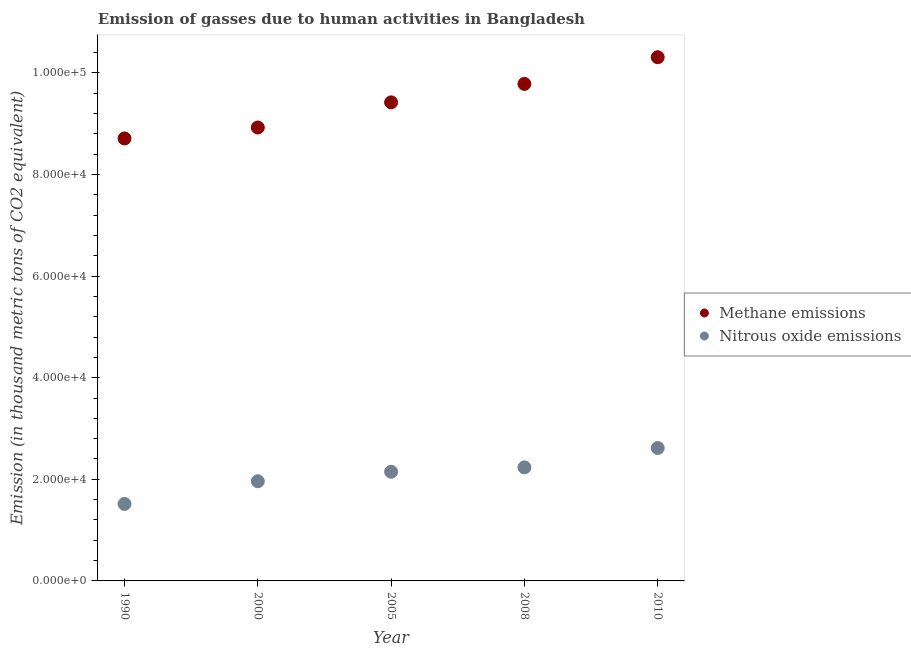How many different coloured dotlines are there?
Offer a very short reply. 2. What is the amount of methane emissions in 2008?
Give a very brief answer. 9.78e+04. Across all years, what is the maximum amount of methane emissions?
Your response must be concise. 1.03e+05. Across all years, what is the minimum amount of methane emissions?
Provide a short and direct response. 8.71e+04. What is the total amount of nitrous oxide emissions in the graph?
Your response must be concise. 1.05e+05. What is the difference between the amount of methane emissions in 2005 and that in 2008?
Provide a succinct answer. -3634.3. What is the difference between the amount of nitrous oxide emissions in 1990 and the amount of methane emissions in 2008?
Give a very brief answer. -8.27e+04. What is the average amount of methane emissions per year?
Keep it short and to the point. 9.43e+04. In the year 2010, what is the difference between the amount of methane emissions and amount of nitrous oxide emissions?
Provide a short and direct response. 7.69e+04. In how many years, is the amount of nitrous oxide emissions greater than 56000 thousand metric tons?
Your answer should be very brief. 0. What is the ratio of the amount of nitrous oxide emissions in 1990 to that in 2000?
Keep it short and to the point. 0.77. Is the amount of nitrous oxide emissions in 1990 less than that in 2000?
Give a very brief answer. Yes. What is the difference between the highest and the second highest amount of nitrous oxide emissions?
Your answer should be compact. 3811.2. What is the difference between the highest and the lowest amount of nitrous oxide emissions?
Make the answer very short. 1.10e+04. In how many years, is the amount of methane emissions greater than the average amount of methane emissions taken over all years?
Your answer should be compact. 2. How many dotlines are there?
Your answer should be very brief. 2. What is the difference between two consecutive major ticks on the Y-axis?
Make the answer very short. 2.00e+04. Where does the legend appear in the graph?
Offer a very short reply. Center right. How are the legend labels stacked?
Your answer should be compact. Vertical. What is the title of the graph?
Ensure brevity in your answer.  Emission of gasses due to human activities in Bangladesh. What is the label or title of the X-axis?
Offer a very short reply. Year. What is the label or title of the Y-axis?
Offer a terse response. Emission (in thousand metric tons of CO2 equivalent). What is the Emission (in thousand metric tons of CO2 equivalent) of Methane emissions in 1990?
Offer a terse response. 8.71e+04. What is the Emission (in thousand metric tons of CO2 equivalent) in Nitrous oxide emissions in 1990?
Your answer should be compact. 1.52e+04. What is the Emission (in thousand metric tons of CO2 equivalent) in Methane emissions in 2000?
Keep it short and to the point. 8.92e+04. What is the Emission (in thousand metric tons of CO2 equivalent) of Nitrous oxide emissions in 2000?
Offer a very short reply. 1.96e+04. What is the Emission (in thousand metric tons of CO2 equivalent) in Methane emissions in 2005?
Offer a terse response. 9.42e+04. What is the Emission (in thousand metric tons of CO2 equivalent) of Nitrous oxide emissions in 2005?
Your response must be concise. 2.15e+04. What is the Emission (in thousand metric tons of CO2 equivalent) in Methane emissions in 2008?
Provide a short and direct response. 9.78e+04. What is the Emission (in thousand metric tons of CO2 equivalent) of Nitrous oxide emissions in 2008?
Your answer should be compact. 2.23e+04. What is the Emission (in thousand metric tons of CO2 equivalent) of Methane emissions in 2010?
Keep it short and to the point. 1.03e+05. What is the Emission (in thousand metric tons of CO2 equivalent) in Nitrous oxide emissions in 2010?
Your answer should be very brief. 2.62e+04. Across all years, what is the maximum Emission (in thousand metric tons of CO2 equivalent) in Methane emissions?
Your answer should be very brief. 1.03e+05. Across all years, what is the maximum Emission (in thousand metric tons of CO2 equivalent) in Nitrous oxide emissions?
Provide a succinct answer. 2.62e+04. Across all years, what is the minimum Emission (in thousand metric tons of CO2 equivalent) of Methane emissions?
Make the answer very short. 8.71e+04. Across all years, what is the minimum Emission (in thousand metric tons of CO2 equivalent) of Nitrous oxide emissions?
Offer a terse response. 1.52e+04. What is the total Emission (in thousand metric tons of CO2 equivalent) of Methane emissions in the graph?
Your answer should be very brief. 4.71e+05. What is the total Emission (in thousand metric tons of CO2 equivalent) in Nitrous oxide emissions in the graph?
Give a very brief answer. 1.05e+05. What is the difference between the Emission (in thousand metric tons of CO2 equivalent) in Methane emissions in 1990 and that in 2000?
Your answer should be compact. -2153.8. What is the difference between the Emission (in thousand metric tons of CO2 equivalent) in Nitrous oxide emissions in 1990 and that in 2000?
Ensure brevity in your answer.  -4463.6. What is the difference between the Emission (in thousand metric tons of CO2 equivalent) of Methane emissions in 1990 and that in 2005?
Your answer should be compact. -7104.5. What is the difference between the Emission (in thousand metric tons of CO2 equivalent) of Nitrous oxide emissions in 1990 and that in 2005?
Provide a short and direct response. -6336.1. What is the difference between the Emission (in thousand metric tons of CO2 equivalent) of Methane emissions in 1990 and that in 2008?
Your response must be concise. -1.07e+04. What is the difference between the Emission (in thousand metric tons of CO2 equivalent) of Nitrous oxide emissions in 1990 and that in 2008?
Your answer should be compact. -7197.8. What is the difference between the Emission (in thousand metric tons of CO2 equivalent) in Methane emissions in 1990 and that in 2010?
Give a very brief answer. -1.60e+04. What is the difference between the Emission (in thousand metric tons of CO2 equivalent) in Nitrous oxide emissions in 1990 and that in 2010?
Make the answer very short. -1.10e+04. What is the difference between the Emission (in thousand metric tons of CO2 equivalent) of Methane emissions in 2000 and that in 2005?
Provide a short and direct response. -4950.7. What is the difference between the Emission (in thousand metric tons of CO2 equivalent) of Nitrous oxide emissions in 2000 and that in 2005?
Your response must be concise. -1872.5. What is the difference between the Emission (in thousand metric tons of CO2 equivalent) of Methane emissions in 2000 and that in 2008?
Ensure brevity in your answer.  -8585. What is the difference between the Emission (in thousand metric tons of CO2 equivalent) of Nitrous oxide emissions in 2000 and that in 2008?
Keep it short and to the point. -2734.2. What is the difference between the Emission (in thousand metric tons of CO2 equivalent) in Methane emissions in 2000 and that in 2010?
Offer a terse response. -1.38e+04. What is the difference between the Emission (in thousand metric tons of CO2 equivalent) of Nitrous oxide emissions in 2000 and that in 2010?
Offer a very short reply. -6545.4. What is the difference between the Emission (in thousand metric tons of CO2 equivalent) of Methane emissions in 2005 and that in 2008?
Your answer should be very brief. -3634.3. What is the difference between the Emission (in thousand metric tons of CO2 equivalent) of Nitrous oxide emissions in 2005 and that in 2008?
Provide a succinct answer. -861.7. What is the difference between the Emission (in thousand metric tons of CO2 equivalent) of Methane emissions in 2005 and that in 2010?
Make the answer very short. -8885.7. What is the difference between the Emission (in thousand metric tons of CO2 equivalent) in Nitrous oxide emissions in 2005 and that in 2010?
Offer a very short reply. -4672.9. What is the difference between the Emission (in thousand metric tons of CO2 equivalent) in Methane emissions in 2008 and that in 2010?
Your answer should be compact. -5251.4. What is the difference between the Emission (in thousand metric tons of CO2 equivalent) of Nitrous oxide emissions in 2008 and that in 2010?
Make the answer very short. -3811.2. What is the difference between the Emission (in thousand metric tons of CO2 equivalent) of Methane emissions in 1990 and the Emission (in thousand metric tons of CO2 equivalent) of Nitrous oxide emissions in 2000?
Offer a terse response. 6.75e+04. What is the difference between the Emission (in thousand metric tons of CO2 equivalent) of Methane emissions in 1990 and the Emission (in thousand metric tons of CO2 equivalent) of Nitrous oxide emissions in 2005?
Provide a short and direct response. 6.56e+04. What is the difference between the Emission (in thousand metric tons of CO2 equivalent) of Methane emissions in 1990 and the Emission (in thousand metric tons of CO2 equivalent) of Nitrous oxide emissions in 2008?
Your response must be concise. 6.47e+04. What is the difference between the Emission (in thousand metric tons of CO2 equivalent) of Methane emissions in 1990 and the Emission (in thousand metric tons of CO2 equivalent) of Nitrous oxide emissions in 2010?
Make the answer very short. 6.09e+04. What is the difference between the Emission (in thousand metric tons of CO2 equivalent) of Methane emissions in 2000 and the Emission (in thousand metric tons of CO2 equivalent) of Nitrous oxide emissions in 2005?
Your answer should be very brief. 6.78e+04. What is the difference between the Emission (in thousand metric tons of CO2 equivalent) of Methane emissions in 2000 and the Emission (in thousand metric tons of CO2 equivalent) of Nitrous oxide emissions in 2008?
Provide a short and direct response. 6.69e+04. What is the difference between the Emission (in thousand metric tons of CO2 equivalent) of Methane emissions in 2000 and the Emission (in thousand metric tons of CO2 equivalent) of Nitrous oxide emissions in 2010?
Your response must be concise. 6.31e+04. What is the difference between the Emission (in thousand metric tons of CO2 equivalent) of Methane emissions in 2005 and the Emission (in thousand metric tons of CO2 equivalent) of Nitrous oxide emissions in 2008?
Your answer should be very brief. 7.18e+04. What is the difference between the Emission (in thousand metric tons of CO2 equivalent) in Methane emissions in 2005 and the Emission (in thousand metric tons of CO2 equivalent) in Nitrous oxide emissions in 2010?
Your answer should be compact. 6.80e+04. What is the difference between the Emission (in thousand metric tons of CO2 equivalent) in Methane emissions in 2008 and the Emission (in thousand metric tons of CO2 equivalent) in Nitrous oxide emissions in 2010?
Keep it short and to the point. 7.17e+04. What is the average Emission (in thousand metric tons of CO2 equivalent) in Methane emissions per year?
Your answer should be compact. 9.43e+04. What is the average Emission (in thousand metric tons of CO2 equivalent) in Nitrous oxide emissions per year?
Your answer should be very brief. 2.10e+04. In the year 1990, what is the difference between the Emission (in thousand metric tons of CO2 equivalent) in Methane emissions and Emission (in thousand metric tons of CO2 equivalent) in Nitrous oxide emissions?
Your answer should be compact. 7.19e+04. In the year 2000, what is the difference between the Emission (in thousand metric tons of CO2 equivalent) in Methane emissions and Emission (in thousand metric tons of CO2 equivalent) in Nitrous oxide emissions?
Offer a very short reply. 6.96e+04. In the year 2005, what is the difference between the Emission (in thousand metric tons of CO2 equivalent) of Methane emissions and Emission (in thousand metric tons of CO2 equivalent) of Nitrous oxide emissions?
Provide a succinct answer. 7.27e+04. In the year 2008, what is the difference between the Emission (in thousand metric tons of CO2 equivalent) of Methane emissions and Emission (in thousand metric tons of CO2 equivalent) of Nitrous oxide emissions?
Make the answer very short. 7.55e+04. In the year 2010, what is the difference between the Emission (in thousand metric tons of CO2 equivalent) of Methane emissions and Emission (in thousand metric tons of CO2 equivalent) of Nitrous oxide emissions?
Your answer should be very brief. 7.69e+04. What is the ratio of the Emission (in thousand metric tons of CO2 equivalent) in Methane emissions in 1990 to that in 2000?
Your response must be concise. 0.98. What is the ratio of the Emission (in thousand metric tons of CO2 equivalent) of Nitrous oxide emissions in 1990 to that in 2000?
Your answer should be compact. 0.77. What is the ratio of the Emission (in thousand metric tons of CO2 equivalent) of Methane emissions in 1990 to that in 2005?
Offer a very short reply. 0.92. What is the ratio of the Emission (in thousand metric tons of CO2 equivalent) in Nitrous oxide emissions in 1990 to that in 2005?
Your response must be concise. 0.71. What is the ratio of the Emission (in thousand metric tons of CO2 equivalent) in Methane emissions in 1990 to that in 2008?
Provide a short and direct response. 0.89. What is the ratio of the Emission (in thousand metric tons of CO2 equivalent) in Nitrous oxide emissions in 1990 to that in 2008?
Offer a terse response. 0.68. What is the ratio of the Emission (in thousand metric tons of CO2 equivalent) of Methane emissions in 1990 to that in 2010?
Keep it short and to the point. 0.84. What is the ratio of the Emission (in thousand metric tons of CO2 equivalent) of Nitrous oxide emissions in 1990 to that in 2010?
Offer a very short reply. 0.58. What is the ratio of the Emission (in thousand metric tons of CO2 equivalent) of Nitrous oxide emissions in 2000 to that in 2005?
Offer a terse response. 0.91. What is the ratio of the Emission (in thousand metric tons of CO2 equivalent) in Methane emissions in 2000 to that in 2008?
Give a very brief answer. 0.91. What is the ratio of the Emission (in thousand metric tons of CO2 equivalent) of Nitrous oxide emissions in 2000 to that in 2008?
Your response must be concise. 0.88. What is the ratio of the Emission (in thousand metric tons of CO2 equivalent) in Methane emissions in 2000 to that in 2010?
Ensure brevity in your answer.  0.87. What is the ratio of the Emission (in thousand metric tons of CO2 equivalent) of Nitrous oxide emissions in 2000 to that in 2010?
Provide a short and direct response. 0.75. What is the ratio of the Emission (in thousand metric tons of CO2 equivalent) in Methane emissions in 2005 to that in 2008?
Keep it short and to the point. 0.96. What is the ratio of the Emission (in thousand metric tons of CO2 equivalent) of Nitrous oxide emissions in 2005 to that in 2008?
Offer a terse response. 0.96. What is the ratio of the Emission (in thousand metric tons of CO2 equivalent) of Methane emissions in 2005 to that in 2010?
Keep it short and to the point. 0.91. What is the ratio of the Emission (in thousand metric tons of CO2 equivalent) of Nitrous oxide emissions in 2005 to that in 2010?
Provide a short and direct response. 0.82. What is the ratio of the Emission (in thousand metric tons of CO2 equivalent) of Methane emissions in 2008 to that in 2010?
Your answer should be compact. 0.95. What is the ratio of the Emission (in thousand metric tons of CO2 equivalent) of Nitrous oxide emissions in 2008 to that in 2010?
Ensure brevity in your answer.  0.85. What is the difference between the highest and the second highest Emission (in thousand metric tons of CO2 equivalent) in Methane emissions?
Make the answer very short. 5251.4. What is the difference between the highest and the second highest Emission (in thousand metric tons of CO2 equivalent) in Nitrous oxide emissions?
Your answer should be very brief. 3811.2. What is the difference between the highest and the lowest Emission (in thousand metric tons of CO2 equivalent) in Methane emissions?
Your response must be concise. 1.60e+04. What is the difference between the highest and the lowest Emission (in thousand metric tons of CO2 equivalent) of Nitrous oxide emissions?
Offer a very short reply. 1.10e+04. 